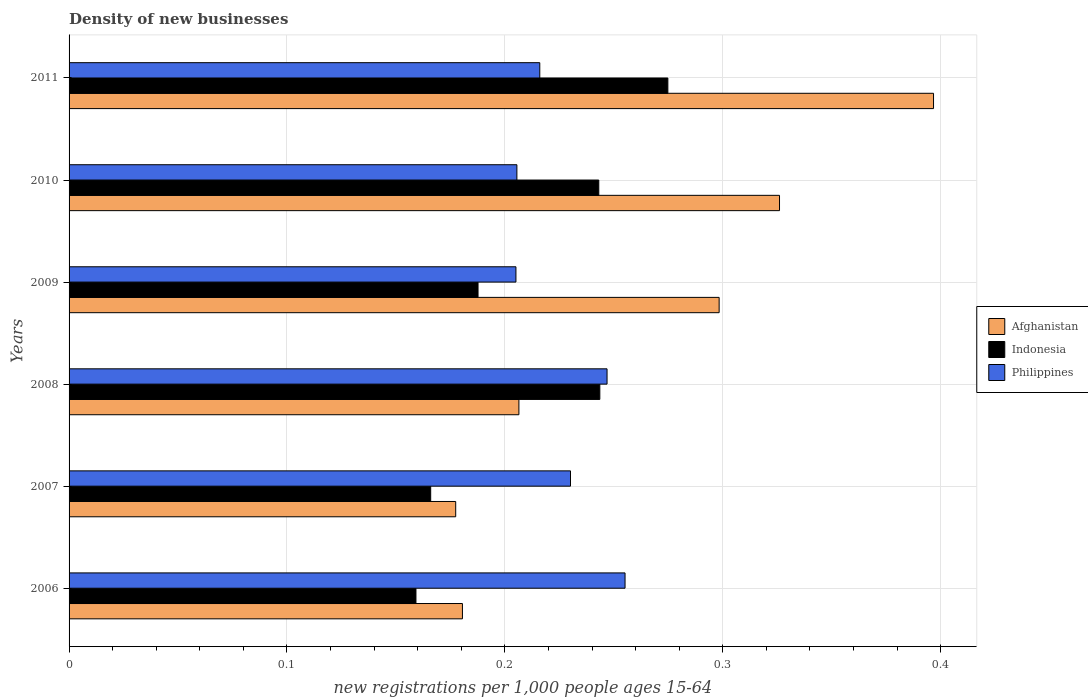Are the number of bars per tick equal to the number of legend labels?
Offer a terse response. Yes. Are the number of bars on each tick of the Y-axis equal?
Your response must be concise. Yes. How many bars are there on the 1st tick from the top?
Keep it short and to the point. 3. How many bars are there on the 6th tick from the bottom?
Your answer should be compact. 3. What is the label of the 4th group of bars from the top?
Keep it short and to the point. 2008. In how many cases, is the number of bars for a given year not equal to the number of legend labels?
Offer a terse response. 0. What is the number of new registrations in Philippines in 2010?
Provide a succinct answer. 0.21. Across all years, what is the maximum number of new registrations in Afghanistan?
Ensure brevity in your answer.  0.4. Across all years, what is the minimum number of new registrations in Afghanistan?
Make the answer very short. 0.18. In which year was the number of new registrations in Indonesia minimum?
Offer a very short reply. 2006. What is the total number of new registrations in Philippines in the graph?
Make the answer very short. 1.36. What is the difference between the number of new registrations in Indonesia in 2006 and that in 2008?
Provide a succinct answer. -0.08. What is the difference between the number of new registrations in Indonesia in 2010 and the number of new registrations in Afghanistan in 2006?
Your answer should be compact. 0.06. What is the average number of new registrations in Indonesia per year?
Provide a short and direct response. 0.21. In the year 2010, what is the difference between the number of new registrations in Afghanistan and number of new registrations in Indonesia?
Your response must be concise. 0.08. In how many years, is the number of new registrations in Indonesia greater than 0.26 ?
Your response must be concise. 1. What is the ratio of the number of new registrations in Philippines in 2009 to that in 2011?
Your answer should be compact. 0.95. What is the difference between the highest and the second highest number of new registrations in Indonesia?
Make the answer very short. 0.03. What is the difference between the highest and the lowest number of new registrations in Philippines?
Provide a short and direct response. 0.05. In how many years, is the number of new registrations in Afghanistan greater than the average number of new registrations in Afghanistan taken over all years?
Provide a succinct answer. 3. Is the sum of the number of new registrations in Afghanistan in 2009 and 2011 greater than the maximum number of new registrations in Indonesia across all years?
Ensure brevity in your answer.  Yes. Is it the case that in every year, the sum of the number of new registrations in Indonesia and number of new registrations in Afghanistan is greater than the number of new registrations in Philippines?
Offer a very short reply. Yes. How many years are there in the graph?
Your answer should be compact. 6. What is the difference between two consecutive major ticks on the X-axis?
Ensure brevity in your answer.  0.1. Does the graph contain any zero values?
Ensure brevity in your answer.  No. Where does the legend appear in the graph?
Your response must be concise. Center right. How are the legend labels stacked?
Your response must be concise. Vertical. What is the title of the graph?
Make the answer very short. Density of new businesses. What is the label or title of the X-axis?
Offer a very short reply. New registrations per 1,0 people ages 15-64. What is the label or title of the Y-axis?
Offer a terse response. Years. What is the new registrations per 1,000 people ages 15-64 of Afghanistan in 2006?
Give a very brief answer. 0.18. What is the new registrations per 1,000 people ages 15-64 of Indonesia in 2006?
Ensure brevity in your answer.  0.16. What is the new registrations per 1,000 people ages 15-64 of Philippines in 2006?
Make the answer very short. 0.26. What is the new registrations per 1,000 people ages 15-64 in Afghanistan in 2007?
Keep it short and to the point. 0.18. What is the new registrations per 1,000 people ages 15-64 in Indonesia in 2007?
Give a very brief answer. 0.17. What is the new registrations per 1,000 people ages 15-64 of Philippines in 2007?
Provide a succinct answer. 0.23. What is the new registrations per 1,000 people ages 15-64 in Afghanistan in 2008?
Ensure brevity in your answer.  0.21. What is the new registrations per 1,000 people ages 15-64 of Indonesia in 2008?
Ensure brevity in your answer.  0.24. What is the new registrations per 1,000 people ages 15-64 in Philippines in 2008?
Your answer should be compact. 0.25. What is the new registrations per 1,000 people ages 15-64 in Afghanistan in 2009?
Keep it short and to the point. 0.3. What is the new registrations per 1,000 people ages 15-64 of Indonesia in 2009?
Provide a succinct answer. 0.19. What is the new registrations per 1,000 people ages 15-64 of Philippines in 2009?
Ensure brevity in your answer.  0.21. What is the new registrations per 1,000 people ages 15-64 of Afghanistan in 2010?
Ensure brevity in your answer.  0.33. What is the new registrations per 1,000 people ages 15-64 in Indonesia in 2010?
Make the answer very short. 0.24. What is the new registrations per 1,000 people ages 15-64 of Philippines in 2010?
Keep it short and to the point. 0.21. What is the new registrations per 1,000 people ages 15-64 in Afghanistan in 2011?
Offer a terse response. 0.4. What is the new registrations per 1,000 people ages 15-64 in Indonesia in 2011?
Your answer should be very brief. 0.27. What is the new registrations per 1,000 people ages 15-64 in Philippines in 2011?
Offer a terse response. 0.22. Across all years, what is the maximum new registrations per 1,000 people ages 15-64 in Afghanistan?
Give a very brief answer. 0.4. Across all years, what is the maximum new registrations per 1,000 people ages 15-64 in Indonesia?
Provide a short and direct response. 0.27. Across all years, what is the maximum new registrations per 1,000 people ages 15-64 of Philippines?
Ensure brevity in your answer.  0.26. Across all years, what is the minimum new registrations per 1,000 people ages 15-64 in Afghanistan?
Offer a very short reply. 0.18. Across all years, what is the minimum new registrations per 1,000 people ages 15-64 of Indonesia?
Keep it short and to the point. 0.16. Across all years, what is the minimum new registrations per 1,000 people ages 15-64 of Philippines?
Keep it short and to the point. 0.21. What is the total new registrations per 1,000 people ages 15-64 of Afghanistan in the graph?
Offer a terse response. 1.59. What is the total new registrations per 1,000 people ages 15-64 of Indonesia in the graph?
Ensure brevity in your answer.  1.27. What is the total new registrations per 1,000 people ages 15-64 in Philippines in the graph?
Offer a terse response. 1.36. What is the difference between the new registrations per 1,000 people ages 15-64 of Afghanistan in 2006 and that in 2007?
Ensure brevity in your answer.  0. What is the difference between the new registrations per 1,000 people ages 15-64 of Indonesia in 2006 and that in 2007?
Offer a terse response. -0.01. What is the difference between the new registrations per 1,000 people ages 15-64 in Philippines in 2006 and that in 2007?
Offer a very short reply. 0.03. What is the difference between the new registrations per 1,000 people ages 15-64 in Afghanistan in 2006 and that in 2008?
Offer a very short reply. -0.03. What is the difference between the new registrations per 1,000 people ages 15-64 of Indonesia in 2006 and that in 2008?
Give a very brief answer. -0.08. What is the difference between the new registrations per 1,000 people ages 15-64 in Philippines in 2006 and that in 2008?
Provide a short and direct response. 0.01. What is the difference between the new registrations per 1,000 people ages 15-64 in Afghanistan in 2006 and that in 2009?
Offer a terse response. -0.12. What is the difference between the new registrations per 1,000 people ages 15-64 of Indonesia in 2006 and that in 2009?
Provide a short and direct response. -0.03. What is the difference between the new registrations per 1,000 people ages 15-64 in Philippines in 2006 and that in 2009?
Offer a terse response. 0.05. What is the difference between the new registrations per 1,000 people ages 15-64 of Afghanistan in 2006 and that in 2010?
Your answer should be compact. -0.15. What is the difference between the new registrations per 1,000 people ages 15-64 of Indonesia in 2006 and that in 2010?
Give a very brief answer. -0.08. What is the difference between the new registrations per 1,000 people ages 15-64 in Philippines in 2006 and that in 2010?
Your answer should be compact. 0.05. What is the difference between the new registrations per 1,000 people ages 15-64 in Afghanistan in 2006 and that in 2011?
Your response must be concise. -0.22. What is the difference between the new registrations per 1,000 people ages 15-64 of Indonesia in 2006 and that in 2011?
Keep it short and to the point. -0.12. What is the difference between the new registrations per 1,000 people ages 15-64 of Philippines in 2006 and that in 2011?
Offer a terse response. 0.04. What is the difference between the new registrations per 1,000 people ages 15-64 in Afghanistan in 2007 and that in 2008?
Offer a terse response. -0.03. What is the difference between the new registrations per 1,000 people ages 15-64 of Indonesia in 2007 and that in 2008?
Make the answer very short. -0.08. What is the difference between the new registrations per 1,000 people ages 15-64 of Philippines in 2007 and that in 2008?
Provide a succinct answer. -0.02. What is the difference between the new registrations per 1,000 people ages 15-64 in Afghanistan in 2007 and that in 2009?
Provide a short and direct response. -0.12. What is the difference between the new registrations per 1,000 people ages 15-64 in Indonesia in 2007 and that in 2009?
Offer a very short reply. -0.02. What is the difference between the new registrations per 1,000 people ages 15-64 of Philippines in 2007 and that in 2009?
Make the answer very short. 0.03. What is the difference between the new registrations per 1,000 people ages 15-64 of Afghanistan in 2007 and that in 2010?
Your answer should be compact. -0.15. What is the difference between the new registrations per 1,000 people ages 15-64 of Indonesia in 2007 and that in 2010?
Your response must be concise. -0.08. What is the difference between the new registrations per 1,000 people ages 15-64 of Philippines in 2007 and that in 2010?
Give a very brief answer. 0.02. What is the difference between the new registrations per 1,000 people ages 15-64 in Afghanistan in 2007 and that in 2011?
Your answer should be very brief. -0.22. What is the difference between the new registrations per 1,000 people ages 15-64 of Indonesia in 2007 and that in 2011?
Make the answer very short. -0.11. What is the difference between the new registrations per 1,000 people ages 15-64 in Philippines in 2007 and that in 2011?
Ensure brevity in your answer.  0.01. What is the difference between the new registrations per 1,000 people ages 15-64 of Afghanistan in 2008 and that in 2009?
Your answer should be very brief. -0.09. What is the difference between the new registrations per 1,000 people ages 15-64 in Indonesia in 2008 and that in 2009?
Provide a short and direct response. 0.06. What is the difference between the new registrations per 1,000 people ages 15-64 in Philippines in 2008 and that in 2009?
Offer a very short reply. 0.04. What is the difference between the new registrations per 1,000 people ages 15-64 in Afghanistan in 2008 and that in 2010?
Your response must be concise. -0.12. What is the difference between the new registrations per 1,000 people ages 15-64 of Indonesia in 2008 and that in 2010?
Keep it short and to the point. 0. What is the difference between the new registrations per 1,000 people ages 15-64 of Philippines in 2008 and that in 2010?
Ensure brevity in your answer.  0.04. What is the difference between the new registrations per 1,000 people ages 15-64 in Afghanistan in 2008 and that in 2011?
Offer a terse response. -0.19. What is the difference between the new registrations per 1,000 people ages 15-64 of Indonesia in 2008 and that in 2011?
Your answer should be compact. -0.03. What is the difference between the new registrations per 1,000 people ages 15-64 in Philippines in 2008 and that in 2011?
Ensure brevity in your answer.  0.03. What is the difference between the new registrations per 1,000 people ages 15-64 in Afghanistan in 2009 and that in 2010?
Make the answer very short. -0.03. What is the difference between the new registrations per 1,000 people ages 15-64 of Indonesia in 2009 and that in 2010?
Ensure brevity in your answer.  -0.06. What is the difference between the new registrations per 1,000 people ages 15-64 in Philippines in 2009 and that in 2010?
Offer a very short reply. -0. What is the difference between the new registrations per 1,000 people ages 15-64 in Afghanistan in 2009 and that in 2011?
Make the answer very short. -0.1. What is the difference between the new registrations per 1,000 people ages 15-64 of Indonesia in 2009 and that in 2011?
Provide a succinct answer. -0.09. What is the difference between the new registrations per 1,000 people ages 15-64 of Philippines in 2009 and that in 2011?
Your answer should be compact. -0.01. What is the difference between the new registrations per 1,000 people ages 15-64 in Afghanistan in 2010 and that in 2011?
Ensure brevity in your answer.  -0.07. What is the difference between the new registrations per 1,000 people ages 15-64 in Indonesia in 2010 and that in 2011?
Offer a terse response. -0.03. What is the difference between the new registrations per 1,000 people ages 15-64 of Philippines in 2010 and that in 2011?
Your response must be concise. -0.01. What is the difference between the new registrations per 1,000 people ages 15-64 in Afghanistan in 2006 and the new registrations per 1,000 people ages 15-64 in Indonesia in 2007?
Provide a short and direct response. 0.01. What is the difference between the new registrations per 1,000 people ages 15-64 of Afghanistan in 2006 and the new registrations per 1,000 people ages 15-64 of Philippines in 2007?
Your answer should be compact. -0.05. What is the difference between the new registrations per 1,000 people ages 15-64 of Indonesia in 2006 and the new registrations per 1,000 people ages 15-64 of Philippines in 2007?
Keep it short and to the point. -0.07. What is the difference between the new registrations per 1,000 people ages 15-64 in Afghanistan in 2006 and the new registrations per 1,000 people ages 15-64 in Indonesia in 2008?
Provide a short and direct response. -0.06. What is the difference between the new registrations per 1,000 people ages 15-64 of Afghanistan in 2006 and the new registrations per 1,000 people ages 15-64 of Philippines in 2008?
Keep it short and to the point. -0.07. What is the difference between the new registrations per 1,000 people ages 15-64 in Indonesia in 2006 and the new registrations per 1,000 people ages 15-64 in Philippines in 2008?
Your response must be concise. -0.09. What is the difference between the new registrations per 1,000 people ages 15-64 in Afghanistan in 2006 and the new registrations per 1,000 people ages 15-64 in Indonesia in 2009?
Provide a short and direct response. -0.01. What is the difference between the new registrations per 1,000 people ages 15-64 of Afghanistan in 2006 and the new registrations per 1,000 people ages 15-64 of Philippines in 2009?
Keep it short and to the point. -0.02. What is the difference between the new registrations per 1,000 people ages 15-64 of Indonesia in 2006 and the new registrations per 1,000 people ages 15-64 of Philippines in 2009?
Ensure brevity in your answer.  -0.05. What is the difference between the new registrations per 1,000 people ages 15-64 of Afghanistan in 2006 and the new registrations per 1,000 people ages 15-64 of Indonesia in 2010?
Your answer should be very brief. -0.06. What is the difference between the new registrations per 1,000 people ages 15-64 of Afghanistan in 2006 and the new registrations per 1,000 people ages 15-64 of Philippines in 2010?
Your answer should be compact. -0.03. What is the difference between the new registrations per 1,000 people ages 15-64 of Indonesia in 2006 and the new registrations per 1,000 people ages 15-64 of Philippines in 2010?
Give a very brief answer. -0.05. What is the difference between the new registrations per 1,000 people ages 15-64 of Afghanistan in 2006 and the new registrations per 1,000 people ages 15-64 of Indonesia in 2011?
Your answer should be compact. -0.09. What is the difference between the new registrations per 1,000 people ages 15-64 in Afghanistan in 2006 and the new registrations per 1,000 people ages 15-64 in Philippines in 2011?
Offer a very short reply. -0.04. What is the difference between the new registrations per 1,000 people ages 15-64 of Indonesia in 2006 and the new registrations per 1,000 people ages 15-64 of Philippines in 2011?
Your answer should be compact. -0.06. What is the difference between the new registrations per 1,000 people ages 15-64 of Afghanistan in 2007 and the new registrations per 1,000 people ages 15-64 of Indonesia in 2008?
Make the answer very short. -0.07. What is the difference between the new registrations per 1,000 people ages 15-64 of Afghanistan in 2007 and the new registrations per 1,000 people ages 15-64 of Philippines in 2008?
Your answer should be compact. -0.07. What is the difference between the new registrations per 1,000 people ages 15-64 of Indonesia in 2007 and the new registrations per 1,000 people ages 15-64 of Philippines in 2008?
Provide a succinct answer. -0.08. What is the difference between the new registrations per 1,000 people ages 15-64 in Afghanistan in 2007 and the new registrations per 1,000 people ages 15-64 in Indonesia in 2009?
Provide a short and direct response. -0.01. What is the difference between the new registrations per 1,000 people ages 15-64 of Afghanistan in 2007 and the new registrations per 1,000 people ages 15-64 of Philippines in 2009?
Ensure brevity in your answer.  -0.03. What is the difference between the new registrations per 1,000 people ages 15-64 of Indonesia in 2007 and the new registrations per 1,000 people ages 15-64 of Philippines in 2009?
Offer a very short reply. -0.04. What is the difference between the new registrations per 1,000 people ages 15-64 in Afghanistan in 2007 and the new registrations per 1,000 people ages 15-64 in Indonesia in 2010?
Offer a terse response. -0.07. What is the difference between the new registrations per 1,000 people ages 15-64 of Afghanistan in 2007 and the new registrations per 1,000 people ages 15-64 of Philippines in 2010?
Offer a terse response. -0.03. What is the difference between the new registrations per 1,000 people ages 15-64 in Indonesia in 2007 and the new registrations per 1,000 people ages 15-64 in Philippines in 2010?
Offer a terse response. -0.04. What is the difference between the new registrations per 1,000 people ages 15-64 of Afghanistan in 2007 and the new registrations per 1,000 people ages 15-64 of Indonesia in 2011?
Offer a very short reply. -0.1. What is the difference between the new registrations per 1,000 people ages 15-64 in Afghanistan in 2007 and the new registrations per 1,000 people ages 15-64 in Philippines in 2011?
Keep it short and to the point. -0.04. What is the difference between the new registrations per 1,000 people ages 15-64 of Indonesia in 2007 and the new registrations per 1,000 people ages 15-64 of Philippines in 2011?
Provide a succinct answer. -0.05. What is the difference between the new registrations per 1,000 people ages 15-64 in Afghanistan in 2008 and the new registrations per 1,000 people ages 15-64 in Indonesia in 2009?
Make the answer very short. 0.02. What is the difference between the new registrations per 1,000 people ages 15-64 of Afghanistan in 2008 and the new registrations per 1,000 people ages 15-64 of Philippines in 2009?
Ensure brevity in your answer.  0. What is the difference between the new registrations per 1,000 people ages 15-64 of Indonesia in 2008 and the new registrations per 1,000 people ages 15-64 of Philippines in 2009?
Keep it short and to the point. 0.04. What is the difference between the new registrations per 1,000 people ages 15-64 in Afghanistan in 2008 and the new registrations per 1,000 people ages 15-64 in Indonesia in 2010?
Your answer should be compact. -0.04. What is the difference between the new registrations per 1,000 people ages 15-64 in Afghanistan in 2008 and the new registrations per 1,000 people ages 15-64 in Philippines in 2010?
Your answer should be compact. 0. What is the difference between the new registrations per 1,000 people ages 15-64 of Indonesia in 2008 and the new registrations per 1,000 people ages 15-64 of Philippines in 2010?
Provide a short and direct response. 0.04. What is the difference between the new registrations per 1,000 people ages 15-64 in Afghanistan in 2008 and the new registrations per 1,000 people ages 15-64 in Indonesia in 2011?
Give a very brief answer. -0.07. What is the difference between the new registrations per 1,000 people ages 15-64 in Afghanistan in 2008 and the new registrations per 1,000 people ages 15-64 in Philippines in 2011?
Your answer should be very brief. -0.01. What is the difference between the new registrations per 1,000 people ages 15-64 of Indonesia in 2008 and the new registrations per 1,000 people ages 15-64 of Philippines in 2011?
Provide a succinct answer. 0.03. What is the difference between the new registrations per 1,000 people ages 15-64 in Afghanistan in 2009 and the new registrations per 1,000 people ages 15-64 in Indonesia in 2010?
Give a very brief answer. 0.06. What is the difference between the new registrations per 1,000 people ages 15-64 in Afghanistan in 2009 and the new registrations per 1,000 people ages 15-64 in Philippines in 2010?
Provide a succinct answer. 0.09. What is the difference between the new registrations per 1,000 people ages 15-64 in Indonesia in 2009 and the new registrations per 1,000 people ages 15-64 in Philippines in 2010?
Ensure brevity in your answer.  -0.02. What is the difference between the new registrations per 1,000 people ages 15-64 in Afghanistan in 2009 and the new registrations per 1,000 people ages 15-64 in Indonesia in 2011?
Offer a very short reply. 0.02. What is the difference between the new registrations per 1,000 people ages 15-64 in Afghanistan in 2009 and the new registrations per 1,000 people ages 15-64 in Philippines in 2011?
Make the answer very short. 0.08. What is the difference between the new registrations per 1,000 people ages 15-64 of Indonesia in 2009 and the new registrations per 1,000 people ages 15-64 of Philippines in 2011?
Keep it short and to the point. -0.03. What is the difference between the new registrations per 1,000 people ages 15-64 in Afghanistan in 2010 and the new registrations per 1,000 people ages 15-64 in Indonesia in 2011?
Your answer should be very brief. 0.05. What is the difference between the new registrations per 1,000 people ages 15-64 of Afghanistan in 2010 and the new registrations per 1,000 people ages 15-64 of Philippines in 2011?
Your response must be concise. 0.11. What is the difference between the new registrations per 1,000 people ages 15-64 of Indonesia in 2010 and the new registrations per 1,000 people ages 15-64 of Philippines in 2011?
Offer a very short reply. 0.03. What is the average new registrations per 1,000 people ages 15-64 of Afghanistan per year?
Your answer should be compact. 0.26. What is the average new registrations per 1,000 people ages 15-64 of Indonesia per year?
Keep it short and to the point. 0.21. What is the average new registrations per 1,000 people ages 15-64 of Philippines per year?
Keep it short and to the point. 0.23. In the year 2006, what is the difference between the new registrations per 1,000 people ages 15-64 of Afghanistan and new registrations per 1,000 people ages 15-64 of Indonesia?
Your response must be concise. 0.02. In the year 2006, what is the difference between the new registrations per 1,000 people ages 15-64 in Afghanistan and new registrations per 1,000 people ages 15-64 in Philippines?
Provide a short and direct response. -0.07. In the year 2006, what is the difference between the new registrations per 1,000 people ages 15-64 of Indonesia and new registrations per 1,000 people ages 15-64 of Philippines?
Your answer should be compact. -0.1. In the year 2007, what is the difference between the new registrations per 1,000 people ages 15-64 in Afghanistan and new registrations per 1,000 people ages 15-64 in Indonesia?
Give a very brief answer. 0.01. In the year 2007, what is the difference between the new registrations per 1,000 people ages 15-64 of Afghanistan and new registrations per 1,000 people ages 15-64 of Philippines?
Provide a short and direct response. -0.05. In the year 2007, what is the difference between the new registrations per 1,000 people ages 15-64 in Indonesia and new registrations per 1,000 people ages 15-64 in Philippines?
Your answer should be compact. -0.06. In the year 2008, what is the difference between the new registrations per 1,000 people ages 15-64 of Afghanistan and new registrations per 1,000 people ages 15-64 of Indonesia?
Keep it short and to the point. -0.04. In the year 2008, what is the difference between the new registrations per 1,000 people ages 15-64 of Afghanistan and new registrations per 1,000 people ages 15-64 of Philippines?
Your answer should be very brief. -0.04. In the year 2008, what is the difference between the new registrations per 1,000 people ages 15-64 of Indonesia and new registrations per 1,000 people ages 15-64 of Philippines?
Offer a terse response. -0. In the year 2009, what is the difference between the new registrations per 1,000 people ages 15-64 of Afghanistan and new registrations per 1,000 people ages 15-64 of Indonesia?
Provide a succinct answer. 0.11. In the year 2009, what is the difference between the new registrations per 1,000 people ages 15-64 of Afghanistan and new registrations per 1,000 people ages 15-64 of Philippines?
Make the answer very short. 0.09. In the year 2009, what is the difference between the new registrations per 1,000 people ages 15-64 of Indonesia and new registrations per 1,000 people ages 15-64 of Philippines?
Your answer should be compact. -0.02. In the year 2010, what is the difference between the new registrations per 1,000 people ages 15-64 of Afghanistan and new registrations per 1,000 people ages 15-64 of Indonesia?
Your answer should be compact. 0.08. In the year 2010, what is the difference between the new registrations per 1,000 people ages 15-64 of Afghanistan and new registrations per 1,000 people ages 15-64 of Philippines?
Give a very brief answer. 0.12. In the year 2010, what is the difference between the new registrations per 1,000 people ages 15-64 in Indonesia and new registrations per 1,000 people ages 15-64 in Philippines?
Offer a very short reply. 0.04. In the year 2011, what is the difference between the new registrations per 1,000 people ages 15-64 in Afghanistan and new registrations per 1,000 people ages 15-64 in Indonesia?
Your answer should be compact. 0.12. In the year 2011, what is the difference between the new registrations per 1,000 people ages 15-64 in Afghanistan and new registrations per 1,000 people ages 15-64 in Philippines?
Your answer should be compact. 0.18. In the year 2011, what is the difference between the new registrations per 1,000 people ages 15-64 of Indonesia and new registrations per 1,000 people ages 15-64 of Philippines?
Make the answer very short. 0.06. What is the ratio of the new registrations per 1,000 people ages 15-64 in Afghanistan in 2006 to that in 2007?
Offer a very short reply. 1.02. What is the ratio of the new registrations per 1,000 people ages 15-64 in Indonesia in 2006 to that in 2007?
Keep it short and to the point. 0.96. What is the ratio of the new registrations per 1,000 people ages 15-64 in Philippines in 2006 to that in 2007?
Provide a short and direct response. 1.11. What is the ratio of the new registrations per 1,000 people ages 15-64 of Afghanistan in 2006 to that in 2008?
Provide a succinct answer. 0.87. What is the ratio of the new registrations per 1,000 people ages 15-64 of Indonesia in 2006 to that in 2008?
Give a very brief answer. 0.65. What is the ratio of the new registrations per 1,000 people ages 15-64 of Philippines in 2006 to that in 2008?
Ensure brevity in your answer.  1.03. What is the ratio of the new registrations per 1,000 people ages 15-64 in Afghanistan in 2006 to that in 2009?
Provide a succinct answer. 0.61. What is the ratio of the new registrations per 1,000 people ages 15-64 of Indonesia in 2006 to that in 2009?
Give a very brief answer. 0.85. What is the ratio of the new registrations per 1,000 people ages 15-64 in Philippines in 2006 to that in 2009?
Offer a terse response. 1.24. What is the ratio of the new registrations per 1,000 people ages 15-64 in Afghanistan in 2006 to that in 2010?
Ensure brevity in your answer.  0.55. What is the ratio of the new registrations per 1,000 people ages 15-64 in Indonesia in 2006 to that in 2010?
Provide a succinct answer. 0.65. What is the ratio of the new registrations per 1,000 people ages 15-64 of Philippines in 2006 to that in 2010?
Your answer should be compact. 1.24. What is the ratio of the new registrations per 1,000 people ages 15-64 of Afghanistan in 2006 to that in 2011?
Offer a very short reply. 0.46. What is the ratio of the new registrations per 1,000 people ages 15-64 in Indonesia in 2006 to that in 2011?
Ensure brevity in your answer.  0.58. What is the ratio of the new registrations per 1,000 people ages 15-64 of Philippines in 2006 to that in 2011?
Ensure brevity in your answer.  1.18. What is the ratio of the new registrations per 1,000 people ages 15-64 in Afghanistan in 2007 to that in 2008?
Provide a short and direct response. 0.86. What is the ratio of the new registrations per 1,000 people ages 15-64 of Indonesia in 2007 to that in 2008?
Offer a very short reply. 0.68. What is the ratio of the new registrations per 1,000 people ages 15-64 of Philippines in 2007 to that in 2008?
Give a very brief answer. 0.93. What is the ratio of the new registrations per 1,000 people ages 15-64 in Afghanistan in 2007 to that in 2009?
Make the answer very short. 0.59. What is the ratio of the new registrations per 1,000 people ages 15-64 in Indonesia in 2007 to that in 2009?
Make the answer very short. 0.88. What is the ratio of the new registrations per 1,000 people ages 15-64 in Philippines in 2007 to that in 2009?
Your answer should be very brief. 1.12. What is the ratio of the new registrations per 1,000 people ages 15-64 of Afghanistan in 2007 to that in 2010?
Provide a short and direct response. 0.54. What is the ratio of the new registrations per 1,000 people ages 15-64 in Indonesia in 2007 to that in 2010?
Offer a very short reply. 0.68. What is the ratio of the new registrations per 1,000 people ages 15-64 in Philippines in 2007 to that in 2010?
Keep it short and to the point. 1.12. What is the ratio of the new registrations per 1,000 people ages 15-64 of Afghanistan in 2007 to that in 2011?
Offer a terse response. 0.45. What is the ratio of the new registrations per 1,000 people ages 15-64 of Indonesia in 2007 to that in 2011?
Your answer should be compact. 0.6. What is the ratio of the new registrations per 1,000 people ages 15-64 in Philippines in 2007 to that in 2011?
Offer a terse response. 1.07. What is the ratio of the new registrations per 1,000 people ages 15-64 in Afghanistan in 2008 to that in 2009?
Provide a succinct answer. 0.69. What is the ratio of the new registrations per 1,000 people ages 15-64 in Indonesia in 2008 to that in 2009?
Give a very brief answer. 1.3. What is the ratio of the new registrations per 1,000 people ages 15-64 in Philippines in 2008 to that in 2009?
Your answer should be compact. 1.2. What is the ratio of the new registrations per 1,000 people ages 15-64 of Afghanistan in 2008 to that in 2010?
Give a very brief answer. 0.63. What is the ratio of the new registrations per 1,000 people ages 15-64 of Indonesia in 2008 to that in 2010?
Provide a short and direct response. 1. What is the ratio of the new registrations per 1,000 people ages 15-64 of Philippines in 2008 to that in 2010?
Provide a succinct answer. 1.2. What is the ratio of the new registrations per 1,000 people ages 15-64 of Afghanistan in 2008 to that in 2011?
Ensure brevity in your answer.  0.52. What is the ratio of the new registrations per 1,000 people ages 15-64 of Indonesia in 2008 to that in 2011?
Your answer should be compact. 0.89. What is the ratio of the new registrations per 1,000 people ages 15-64 of Afghanistan in 2009 to that in 2010?
Give a very brief answer. 0.92. What is the ratio of the new registrations per 1,000 people ages 15-64 in Indonesia in 2009 to that in 2010?
Your response must be concise. 0.77. What is the ratio of the new registrations per 1,000 people ages 15-64 in Philippines in 2009 to that in 2010?
Your response must be concise. 1. What is the ratio of the new registrations per 1,000 people ages 15-64 in Afghanistan in 2009 to that in 2011?
Your answer should be compact. 0.75. What is the ratio of the new registrations per 1,000 people ages 15-64 in Indonesia in 2009 to that in 2011?
Your answer should be very brief. 0.68. What is the ratio of the new registrations per 1,000 people ages 15-64 of Philippines in 2009 to that in 2011?
Your answer should be compact. 0.95. What is the ratio of the new registrations per 1,000 people ages 15-64 in Afghanistan in 2010 to that in 2011?
Your response must be concise. 0.82. What is the ratio of the new registrations per 1,000 people ages 15-64 of Indonesia in 2010 to that in 2011?
Your answer should be very brief. 0.88. What is the ratio of the new registrations per 1,000 people ages 15-64 of Philippines in 2010 to that in 2011?
Your answer should be very brief. 0.95. What is the difference between the highest and the second highest new registrations per 1,000 people ages 15-64 in Afghanistan?
Offer a terse response. 0.07. What is the difference between the highest and the second highest new registrations per 1,000 people ages 15-64 of Indonesia?
Ensure brevity in your answer.  0.03. What is the difference between the highest and the second highest new registrations per 1,000 people ages 15-64 of Philippines?
Offer a very short reply. 0.01. What is the difference between the highest and the lowest new registrations per 1,000 people ages 15-64 in Afghanistan?
Keep it short and to the point. 0.22. What is the difference between the highest and the lowest new registrations per 1,000 people ages 15-64 of Indonesia?
Offer a very short reply. 0.12. What is the difference between the highest and the lowest new registrations per 1,000 people ages 15-64 of Philippines?
Make the answer very short. 0.05. 